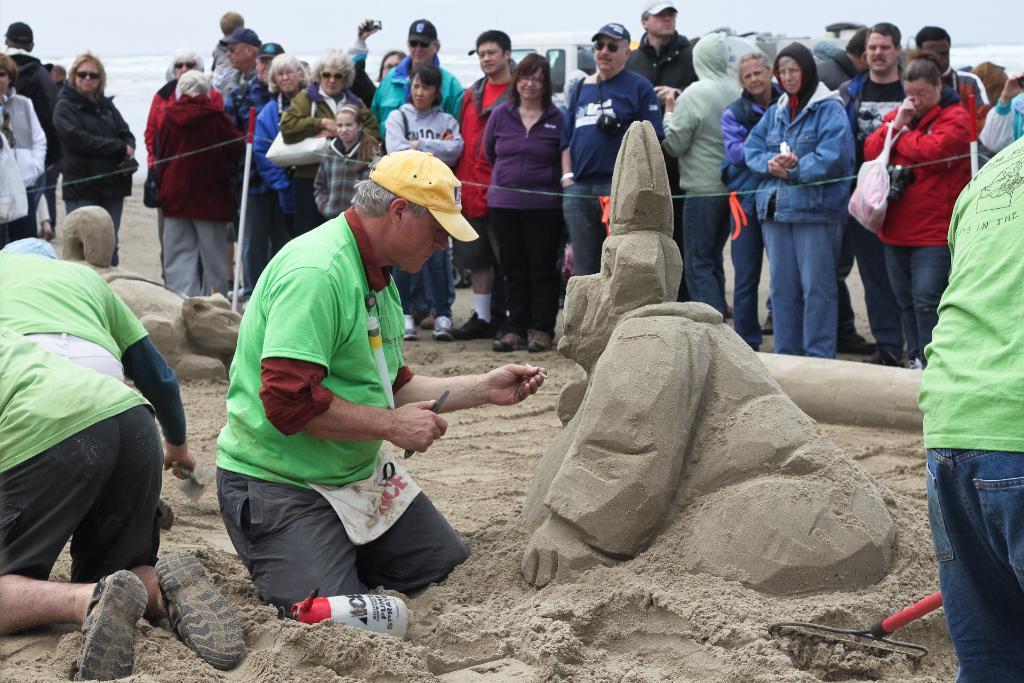Please provide a concise description of this image. In this picture we can see a group of people standing on the ground, sand carvings and some people wore caps, jackets and goggles and some objects and at the back of them we can see a vehicle, water and in the background we can see the sky. 